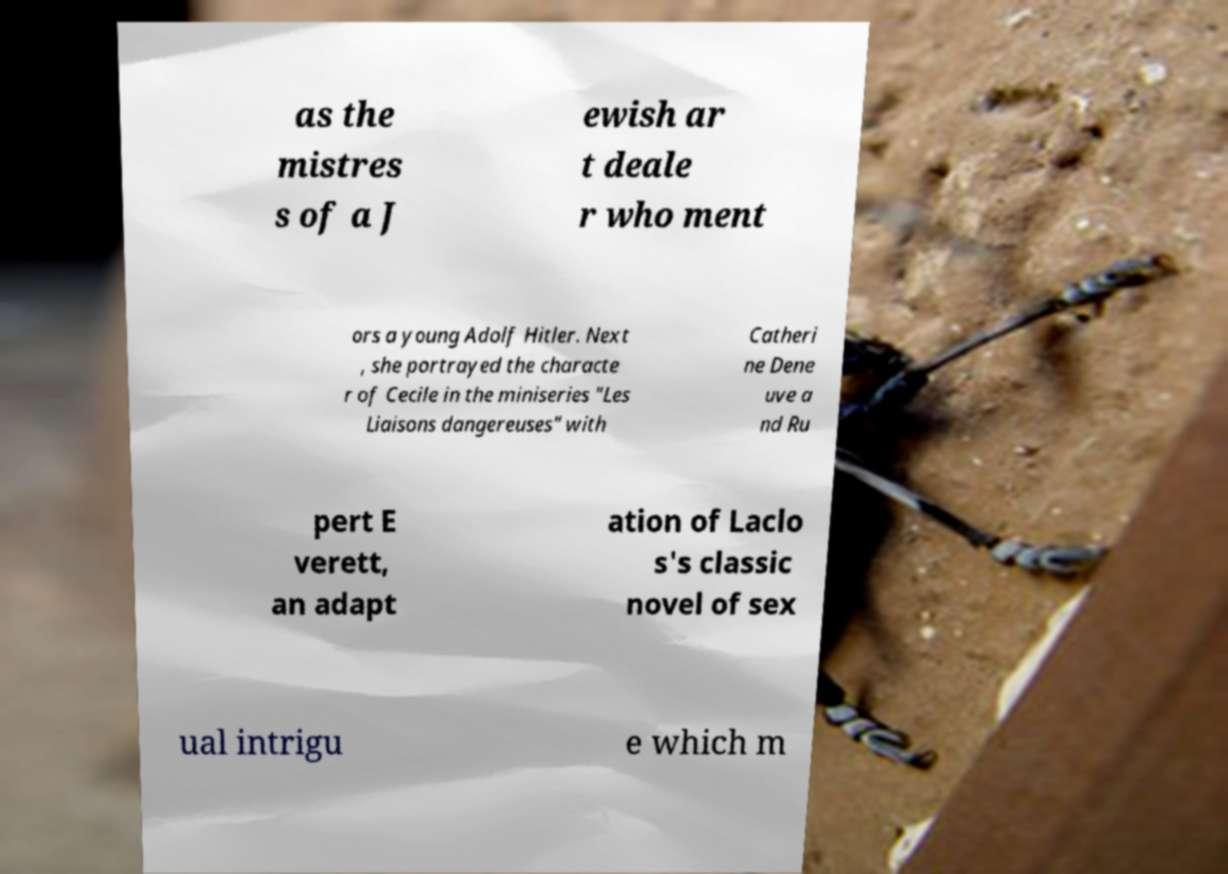For documentation purposes, I need the text within this image transcribed. Could you provide that? as the mistres s of a J ewish ar t deale r who ment ors a young Adolf Hitler. Next , she portrayed the characte r of Cecile in the miniseries "Les Liaisons dangereuses" with Catheri ne Dene uve a nd Ru pert E verett, an adapt ation of Laclo s's classic novel of sex ual intrigu e which m 